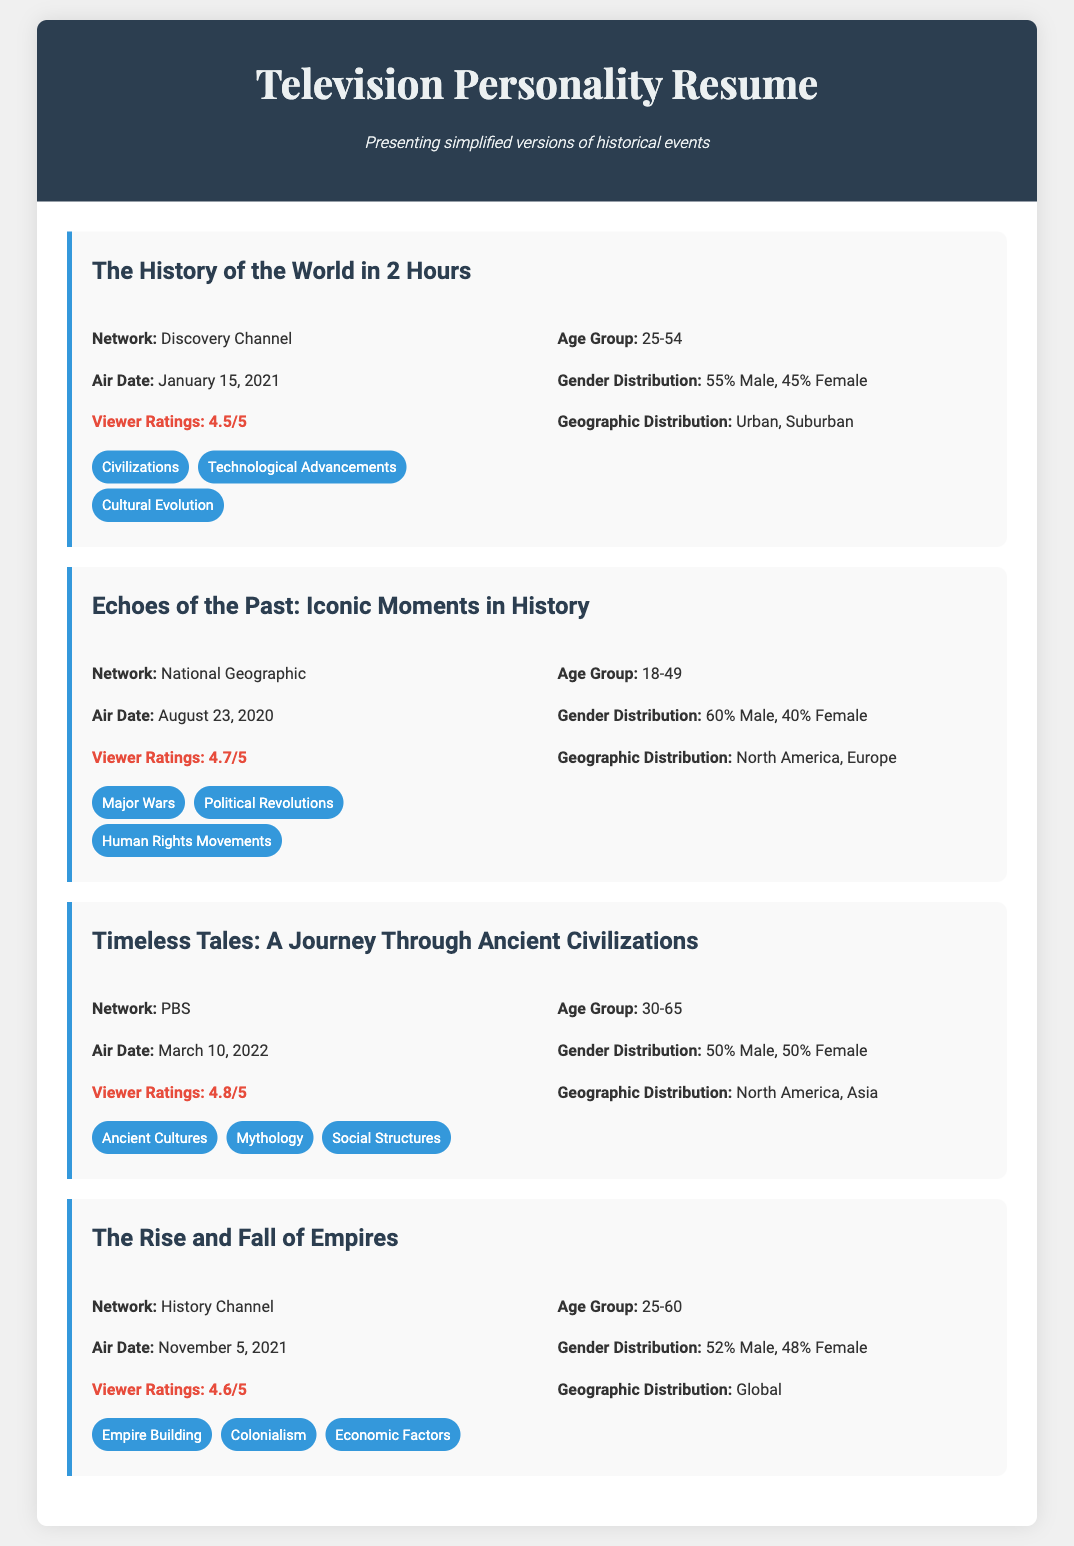What is the title of the show that aired on January 15, 2021? The title of the show is "The History of the World in 2 Hours," which aired on that date.
Answer: The History of the World in 2 Hours What is the viewer rating for "Echoes of the Past: Iconic Moments in History"? The viewer rating for this show is specifically mentioned in the document, which is 4.7 out of 5.
Answer: 4.7/5 Which network aired "Timeless Tales: A Journey Through Ancient Civilizations"? The document specifies that this show was aired by PBS.
Answer: PBS What major historical theme is presented in "The Rise and Fall of Empires"? The document lists "Empire Building" as one of the major themes for this show.
Answer: Empire Building Which show has the highest viewer rating? The document provides viewer ratings for all shows, indicating that "Timeless Tales" has the highest at 4.8 out of 5.
Answer: 4.8/5 What age group primarily watched "The History of the World in 2 Hours"? According to the document, the primary age group is cited as 25-54 years old.
Answer: 25-54 What is the gender distribution for the audience of "Echoes of the Past"? The document outlines the gender distribution, which is 60% Male and 40% Female for this show.
Answer: 60% Male, 40% Female What is the geographic distribution for the audience of "Timeless Tales"? The document states that the audience for this show is distributed across North America and Asia.
Answer: North America, Asia 